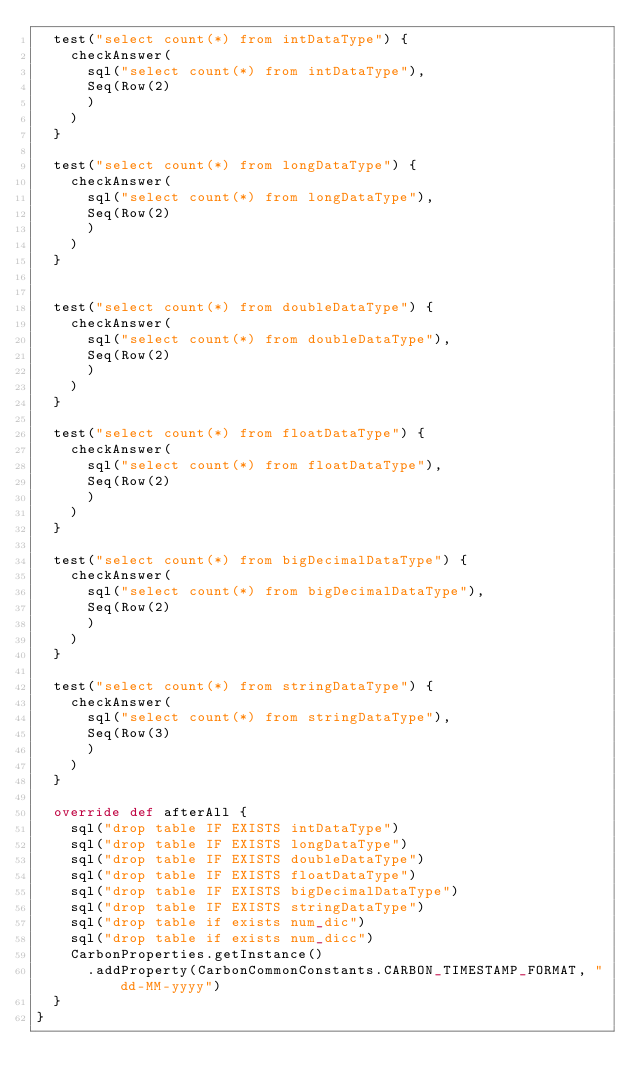Convert code to text. <code><loc_0><loc_0><loc_500><loc_500><_Scala_>  test("select count(*) from intDataType") {
    checkAnswer(
      sql("select count(*) from intDataType"),
      Seq(Row(2)
      )
    )
  }

  test("select count(*) from longDataType") {
    checkAnswer(
      sql("select count(*) from longDataType"),
      Seq(Row(2)
      )
    )
  }


  test("select count(*) from doubleDataType") {
    checkAnswer(
      sql("select count(*) from doubleDataType"),
      Seq(Row(2)
      )
    )
  }

  test("select count(*) from floatDataType") {
    checkAnswer(
      sql("select count(*) from floatDataType"),
      Seq(Row(2)
      )
    )
  }

  test("select count(*) from bigDecimalDataType") {
    checkAnswer(
      sql("select count(*) from bigDecimalDataType"),
      Seq(Row(2)
      )
    )
  }

  test("select count(*) from stringDataType") {
    checkAnswer(
      sql("select count(*) from stringDataType"),
      Seq(Row(3)
      )
    )
  }

  override def afterAll {
    sql("drop table IF EXISTS intDataType")
    sql("drop table IF EXISTS longDataType")
    sql("drop table IF EXISTS doubleDataType")
    sql("drop table IF EXISTS floatDataType")
    sql("drop table IF EXISTS bigDecimalDataType")
    sql("drop table IF EXISTS stringDataType")
    sql("drop table if exists num_dic")
    sql("drop table if exists num_dicc")
    CarbonProperties.getInstance()
      .addProperty(CarbonCommonConstants.CARBON_TIMESTAMP_FORMAT, "dd-MM-yyyy")
  }
}</code> 